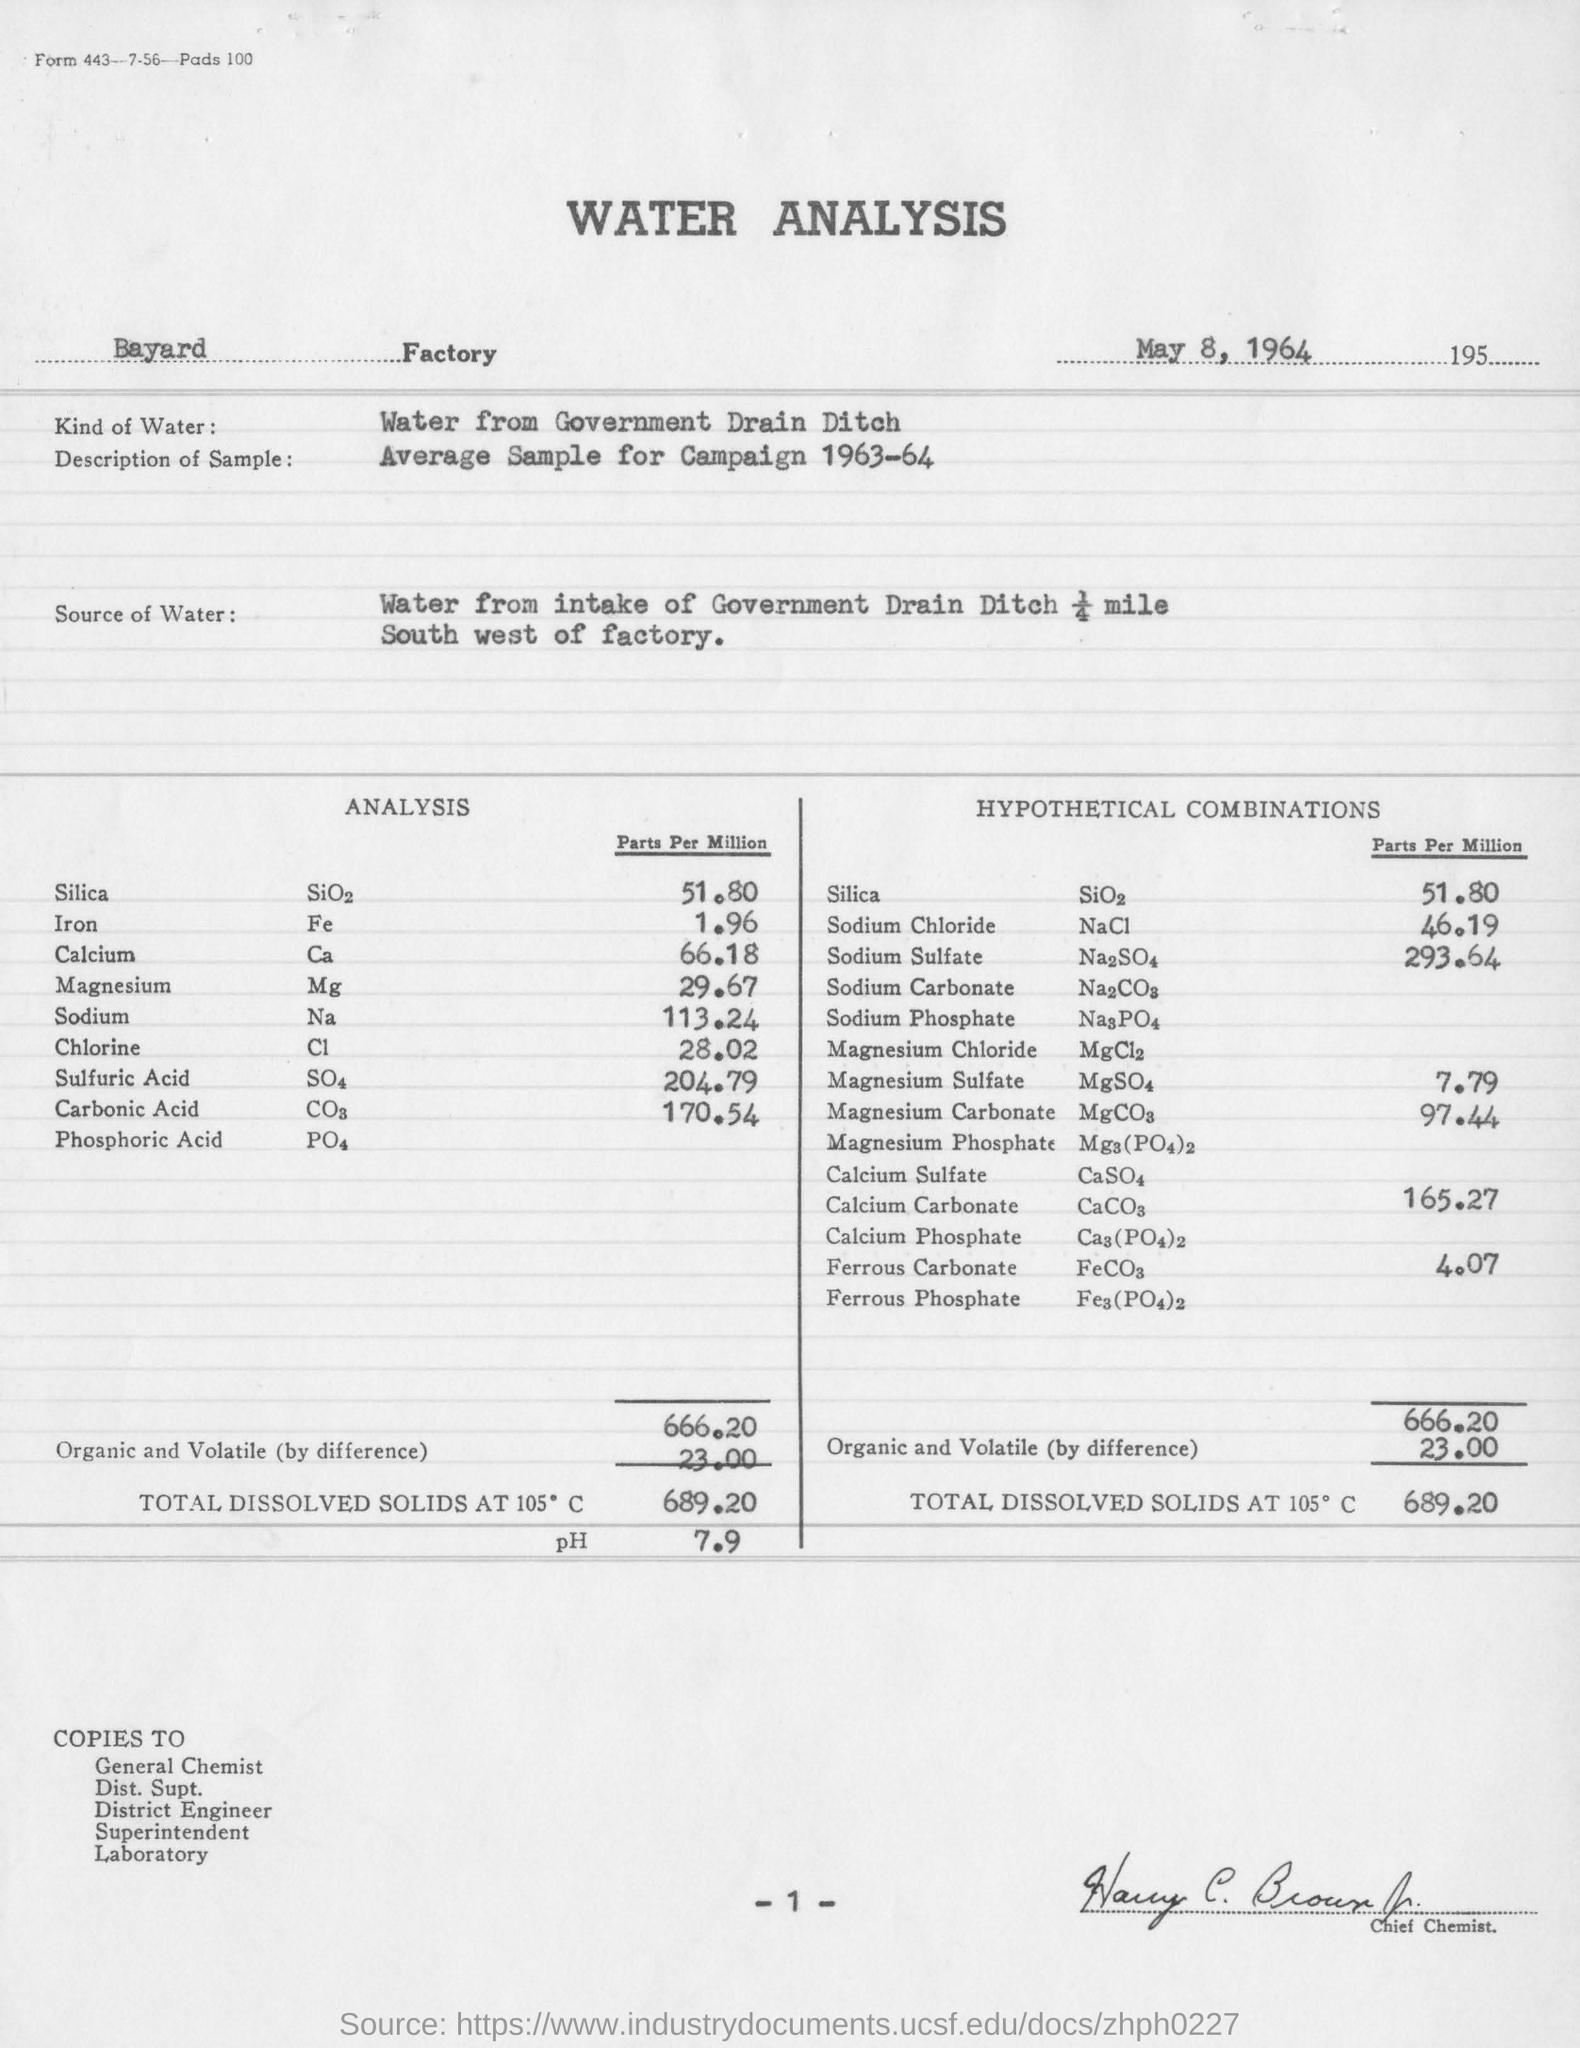What is the name of the factory ?
Give a very brief answer. Bayard Factory. What is the hypothetical combination of sodium sulfate in parts per million ?
Offer a very short reply. 293.64. What is the amount of total dissolved solids at 105 degrees c ?
Your response must be concise. 689.20. What is the ph value of total dissolved solids at 105 degrees c ?
Offer a terse response. 7.9. On which date is this analysis done?
Your answer should be very brief. May 8, 1964. 